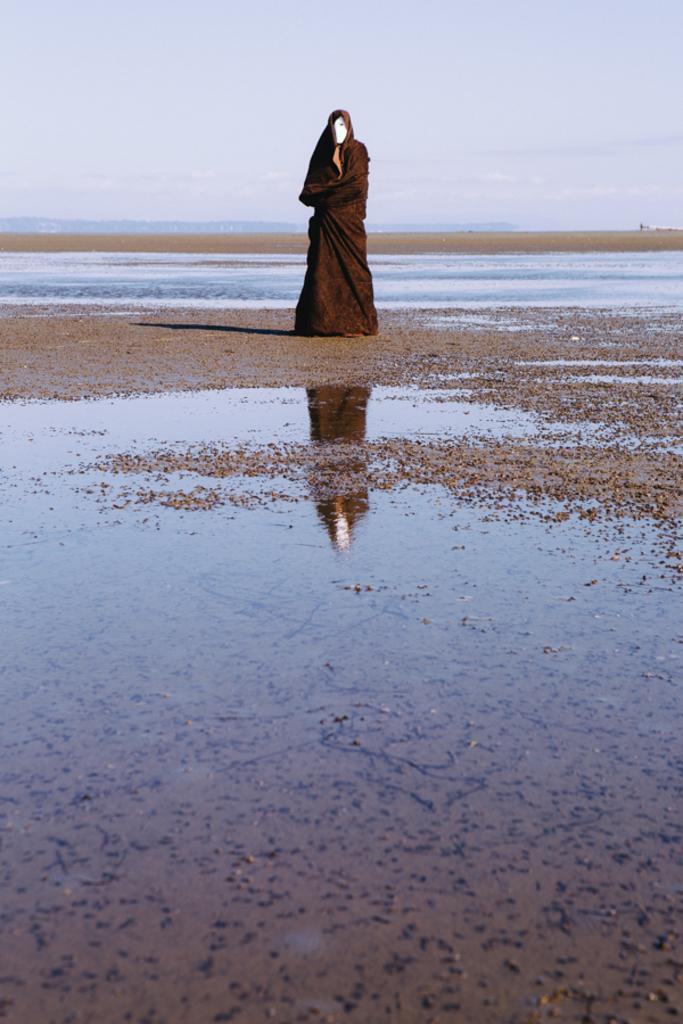Could you give a brief overview of what you see in this image? In this image we can see a person is standing on the ground and there is a mask to the face and the complete body is covered with a black color cloth. We can see water on the ground. In the background we can see clouds in the sky. 